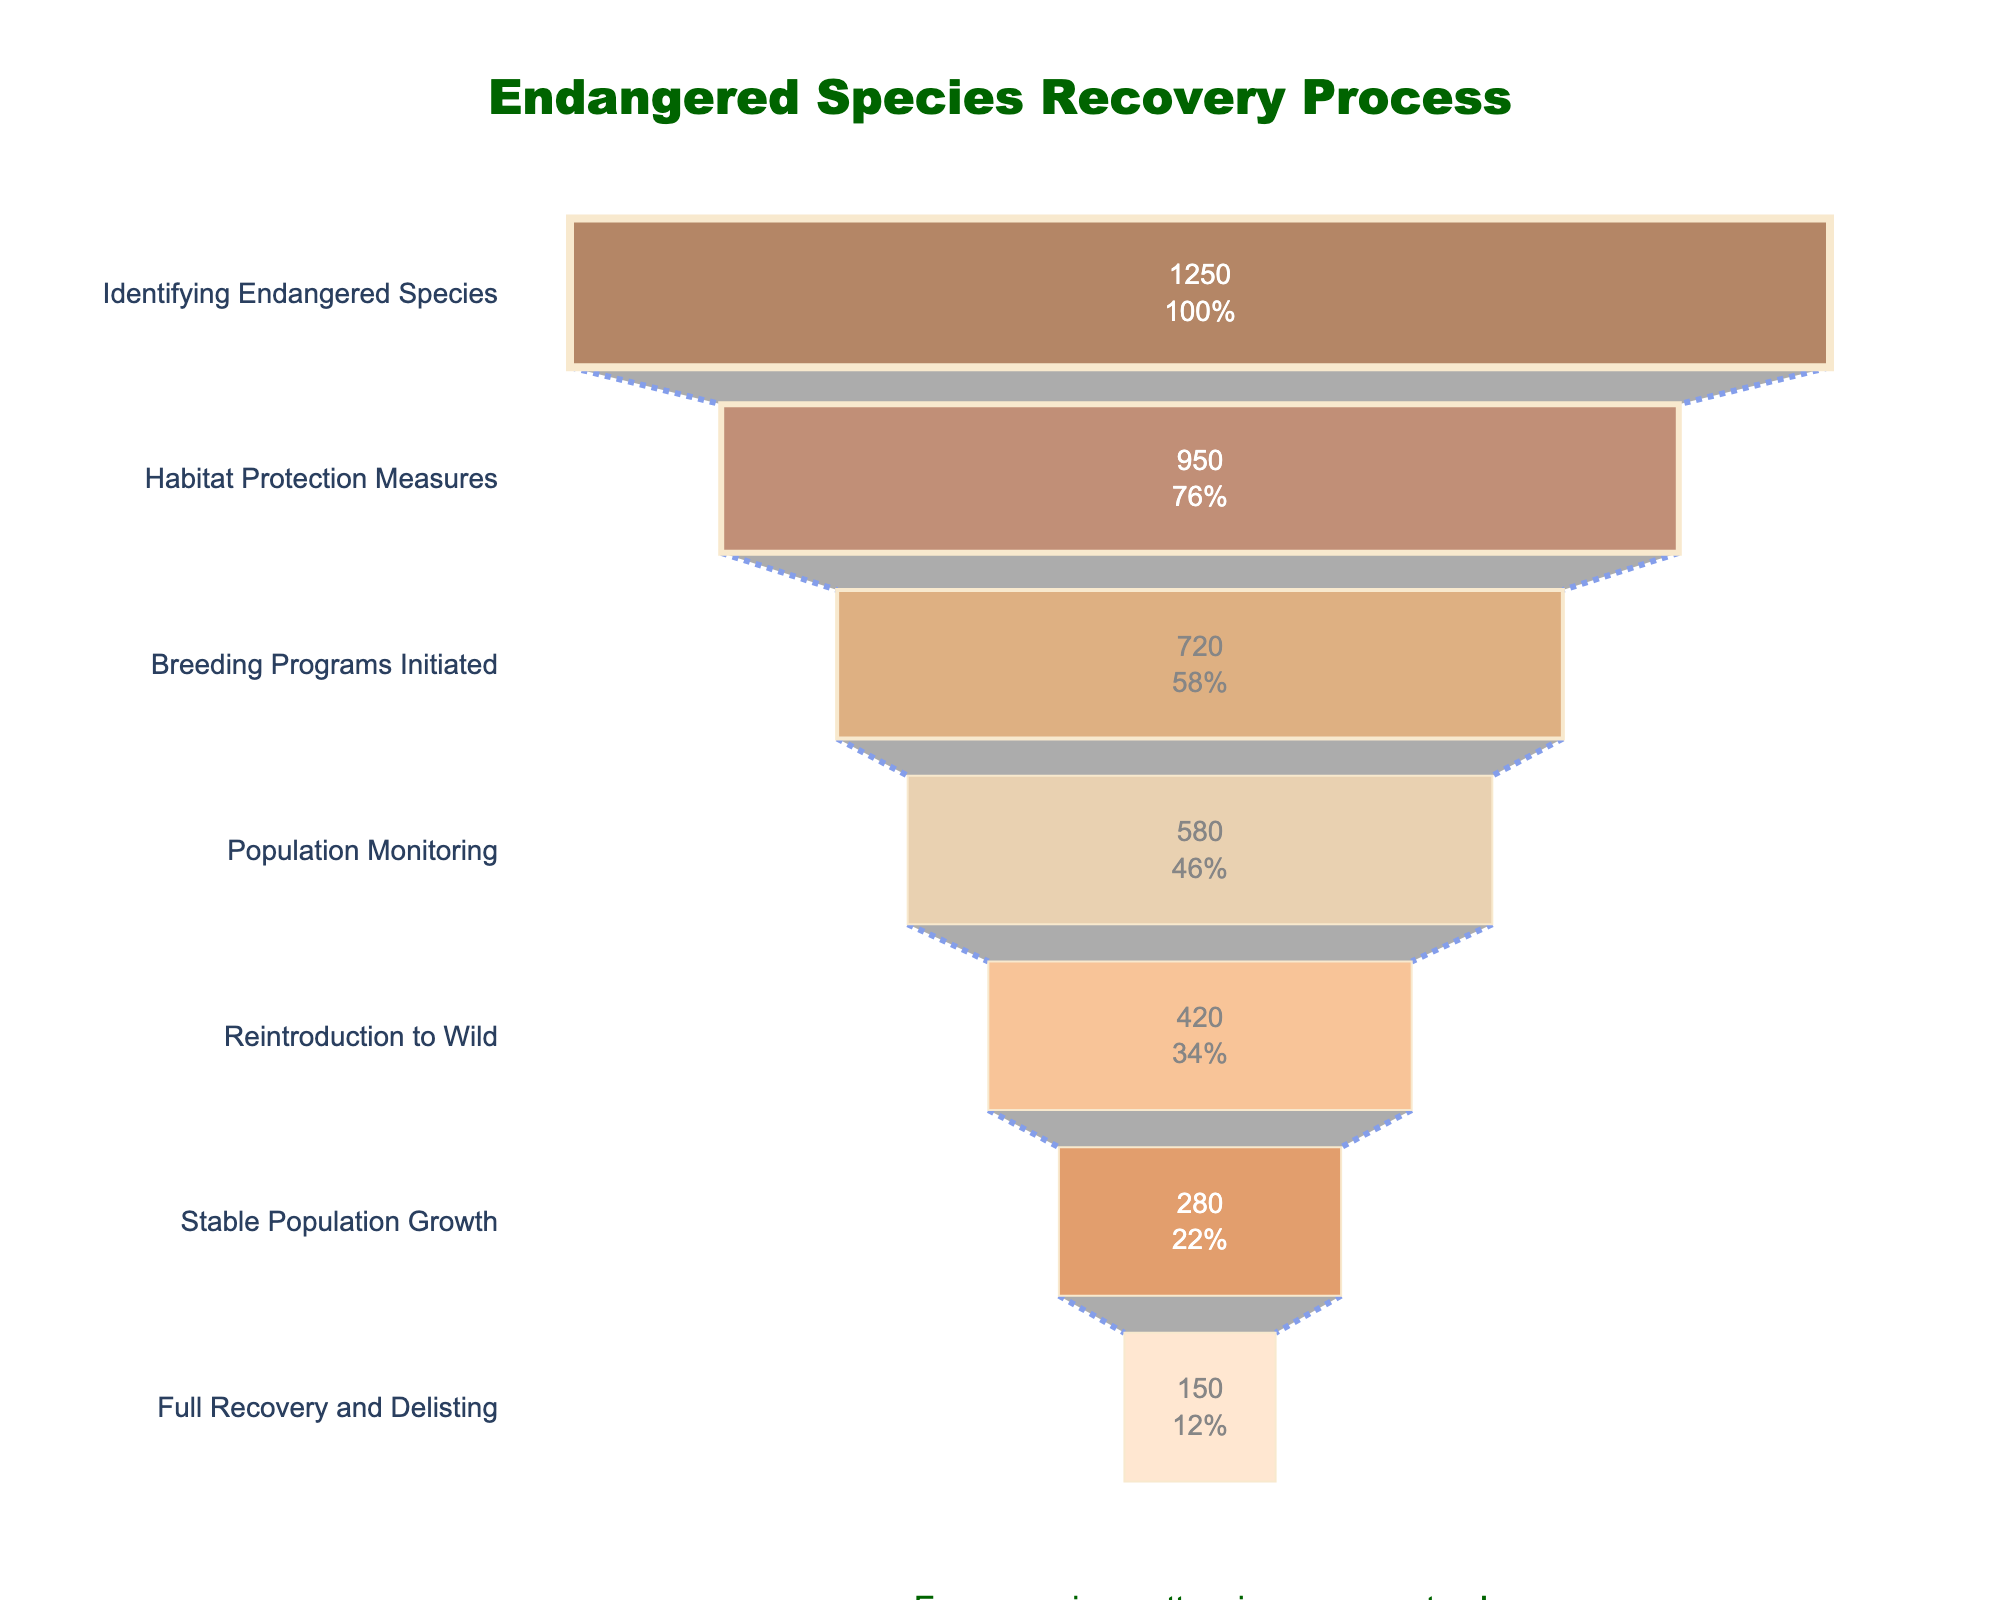What is the title of the chart? The title is located at the top center of the chart, written in larger font size. It summarizes the overall topic of the funnel chart.
Answer: Endangered Species Recovery Process How many stages are shown in the funnel chart? The number of stages can be determined by counting the distinct entries in the y-axis of the funnel chart.
Answer: 7 What is the first stage in the endangered species recovery process? The first stage is listed at the top of the y-axis.
Answer: Identifying Endangered Species Which stage has the highest number of species? The stage with the highest number of species is indicated by the longest segment on the funnel chart, found at the top.
Answer: Identifying Endangered Species What is the color of the stage "Full Recovery and Delisting"? The color of each stage can be identified by looking at the segment representing that stage on the funnel chart.
Answer: Light peach How many species make it to the "Breeding Programs Initiated" stage? The count for each stage is shown inside the funnel chart segments. Locate "Breeding Programs Initiated" and read the count.
Answer: 720 What percentage of species identified as endangered make it to the "Stable Population Growth" stage? Find the percentage listed within the segment for "Stable Population Growth". This represents the proportion out of the initial number identified.
Answer: 22.4% What is the difference in species count between "Habitat Protection Measures" and "Reintroduction to Wild"? Subtract the species count of "Reintroduction to Wild" from the species count of "Habitat Protection Measures".
Answer: 530 How many more species are successfully reintroduced to the wild than the number that reaches full recovery and delisting? Subtract the species count of "Full Recovery and Delisting" from the species count of "Reintroduction to Wild".
Answer: 270 What percentage of species recovery is successfully completed to the final stage compared to the initial identified endangered species? Find the percentage listed inside the segment for "Full Recovery and Delisting". This shows the proportion relative to the initial count.
Answer: 12% 